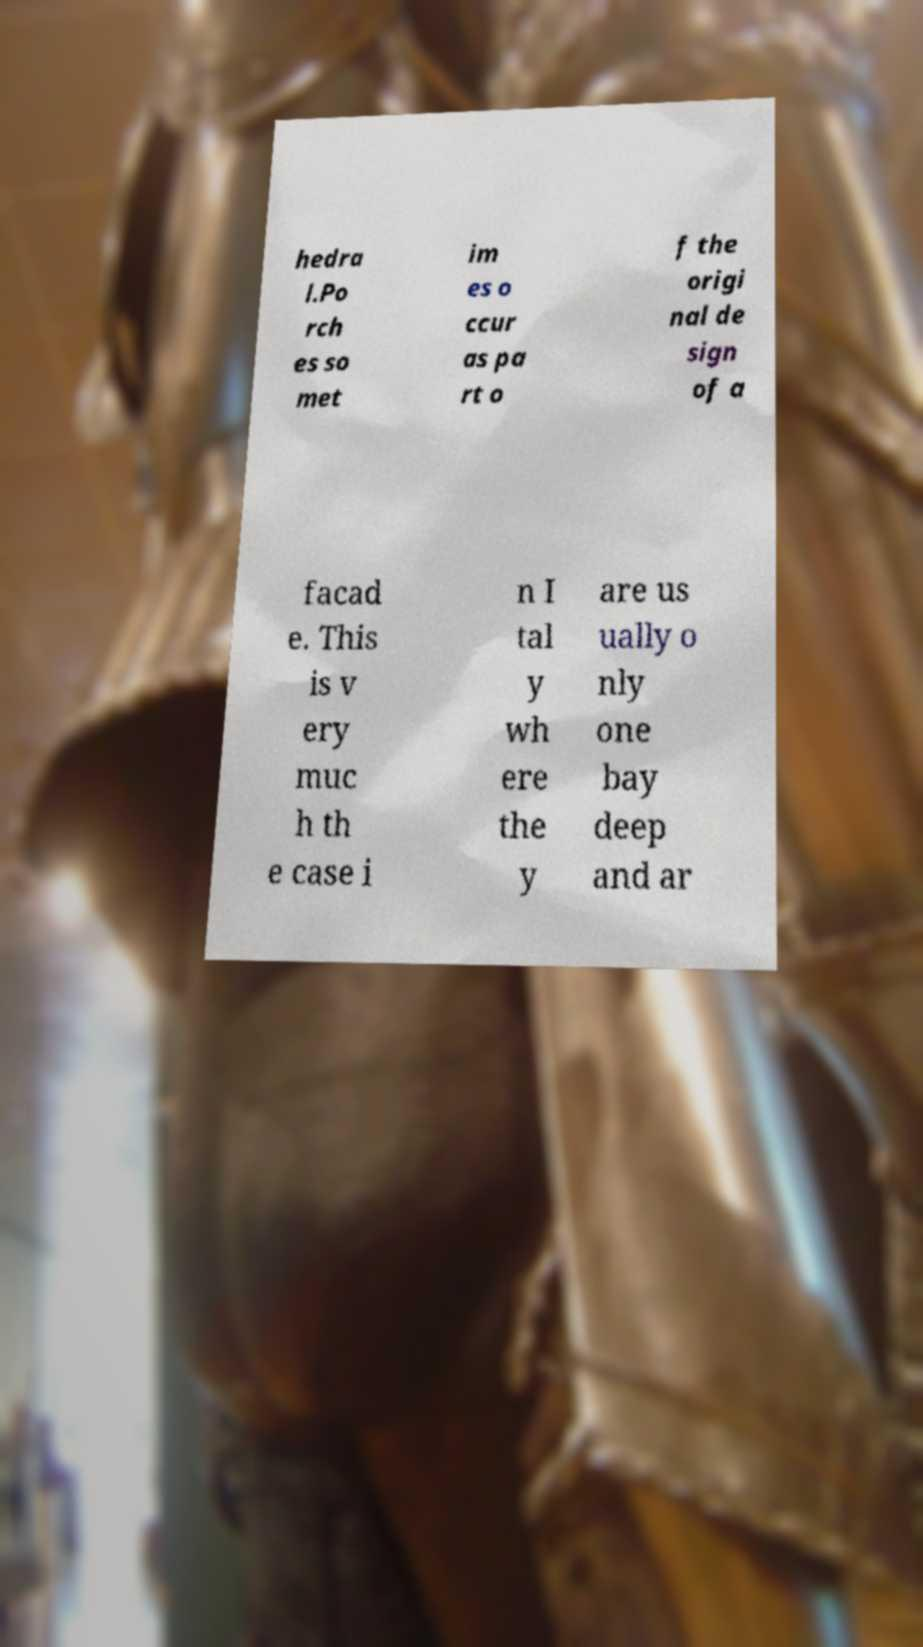There's text embedded in this image that I need extracted. Can you transcribe it verbatim? hedra l.Po rch es so met im es o ccur as pa rt o f the origi nal de sign of a facad e. This is v ery muc h th e case i n I tal y wh ere the y are us ually o nly one bay deep and ar 